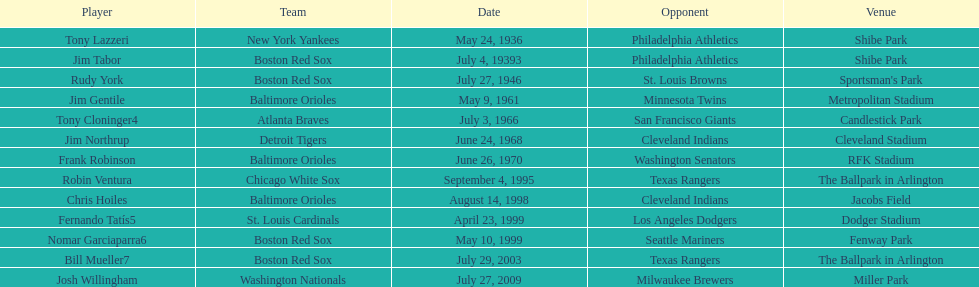Who was the opponent for the boston red sox on july 27, 1946? St. Louis Browns. 